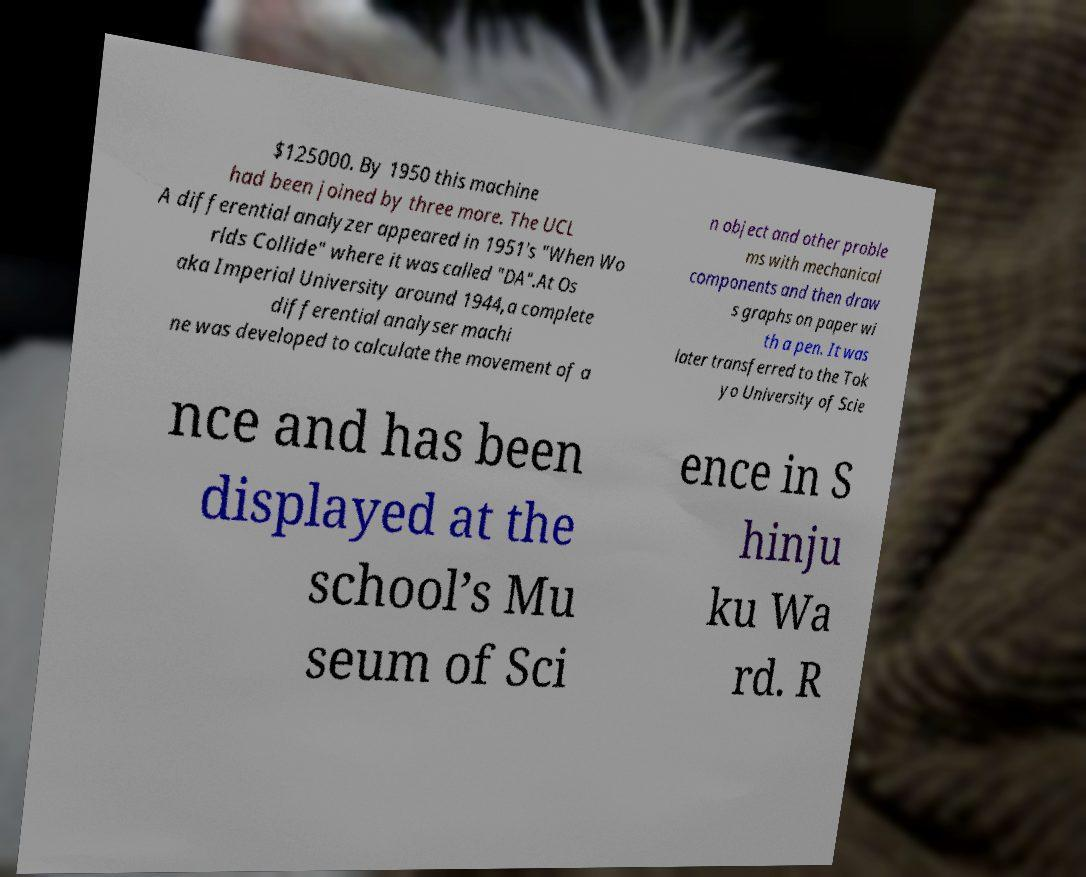There's text embedded in this image that I need extracted. Can you transcribe it verbatim? $125000. By 1950 this machine had been joined by three more. The UCL A differential analyzer appeared in 1951's "When Wo rlds Collide" where it was called "DA".At Os aka Imperial University around 1944,a complete differential analyser machi ne was developed to calculate the movement of a n object and other proble ms with mechanical components and then draw s graphs on paper wi th a pen. It was later transferred to the Tok yo University of Scie nce and has been displayed at the school’s Mu seum of Sci ence in S hinju ku Wa rd. R 